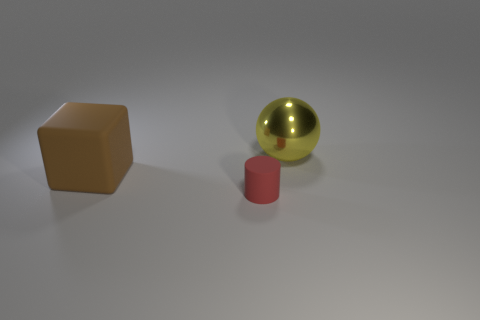Add 1 small blue rubber things. How many objects exist? 4 Subtract 0 yellow cylinders. How many objects are left? 3 Subtract all blocks. How many objects are left? 2 Subtract all big cubes. Subtract all big brown cubes. How many objects are left? 1 Add 3 yellow spheres. How many yellow spheres are left? 4 Add 1 brown rubber cubes. How many brown rubber cubes exist? 2 